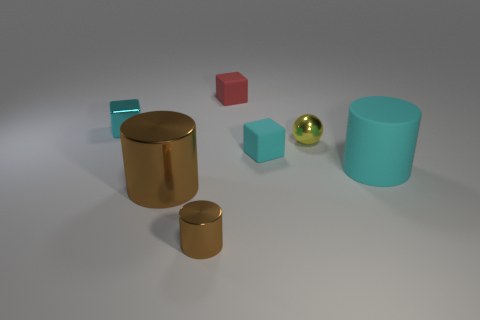What number of objects are cyan matte cubes or objects behind the tiny cyan metallic cube?
Provide a succinct answer. 2. There is a cyan cube to the right of the red rubber object; does it have the same size as the big cyan thing?
Provide a short and direct response. No. What number of other things are there of the same shape as the red object?
Offer a terse response. 2. What number of blue things are either tiny metal cubes or tiny metal spheres?
Your answer should be compact. 0. Is the color of the big thing that is on the right side of the small red object the same as the tiny metallic block?
Your answer should be very brief. Yes. The tiny cyan object that is the same material as the tiny red object is what shape?
Provide a short and direct response. Cube. There is a small object that is in front of the metal ball and right of the red rubber block; what is its color?
Keep it short and to the point. Cyan. How big is the cyan matte object left of the large cylinder that is behind the large brown cylinder?
Your answer should be very brief. Small. Is there a large metal cylinder of the same color as the tiny shiny sphere?
Make the answer very short. No. Are there an equal number of yellow metallic spheres behind the tiny metal ball and tiny cyan metal objects?
Provide a short and direct response. No. 